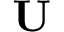Convert formula to latex. <formula><loc_0><loc_0><loc_500><loc_500>U</formula> 